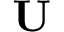Convert formula to latex. <formula><loc_0><loc_0><loc_500><loc_500>U</formula> 